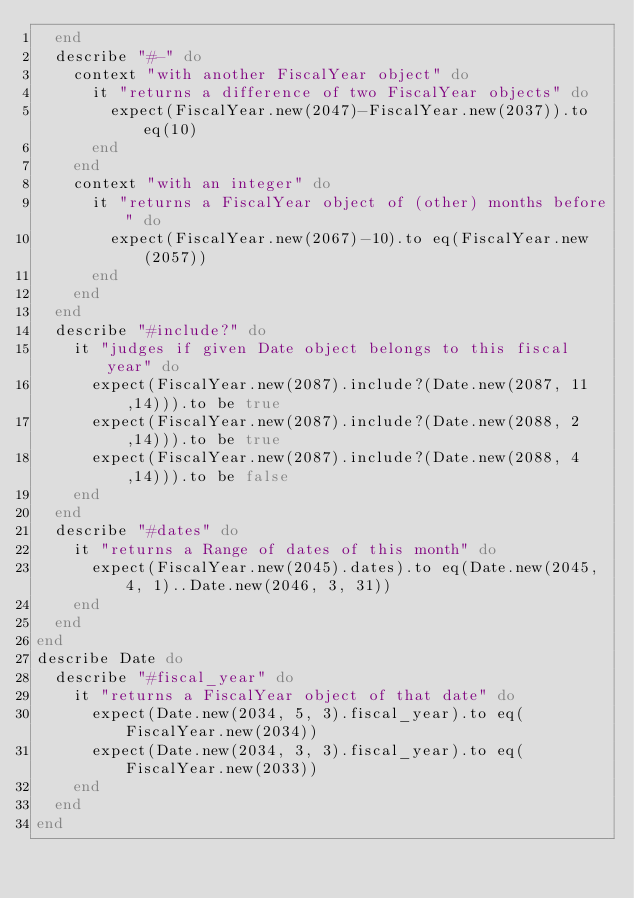Convert code to text. <code><loc_0><loc_0><loc_500><loc_500><_Ruby_>  end
  describe "#-" do
    context "with another FiscalYear object" do
      it "returns a difference of two FiscalYear objects" do
        expect(FiscalYear.new(2047)-FiscalYear.new(2037)).to eq(10)
      end
    end
    context "with an integer" do
      it "returns a FiscalYear object of (other) months before" do
        expect(FiscalYear.new(2067)-10).to eq(FiscalYear.new(2057))
      end
    end
  end
  describe "#include?" do
    it "judges if given Date object belongs to this fiscal year" do
      expect(FiscalYear.new(2087).include?(Date.new(2087, 11 ,14))).to be true
      expect(FiscalYear.new(2087).include?(Date.new(2088, 2 ,14))).to be true
      expect(FiscalYear.new(2087).include?(Date.new(2088, 4 ,14))).to be false
    end
  end
  describe "#dates" do
    it "returns a Range of dates of this month" do
      expect(FiscalYear.new(2045).dates).to eq(Date.new(2045, 4, 1)..Date.new(2046, 3, 31))
    end
  end
end
describe Date do
  describe "#fiscal_year" do
    it "returns a FiscalYear object of that date" do
      expect(Date.new(2034, 5, 3).fiscal_year).to eq(FiscalYear.new(2034))
      expect(Date.new(2034, 3, 3).fiscal_year).to eq(FiscalYear.new(2033))
    end
  end
end
</code> 